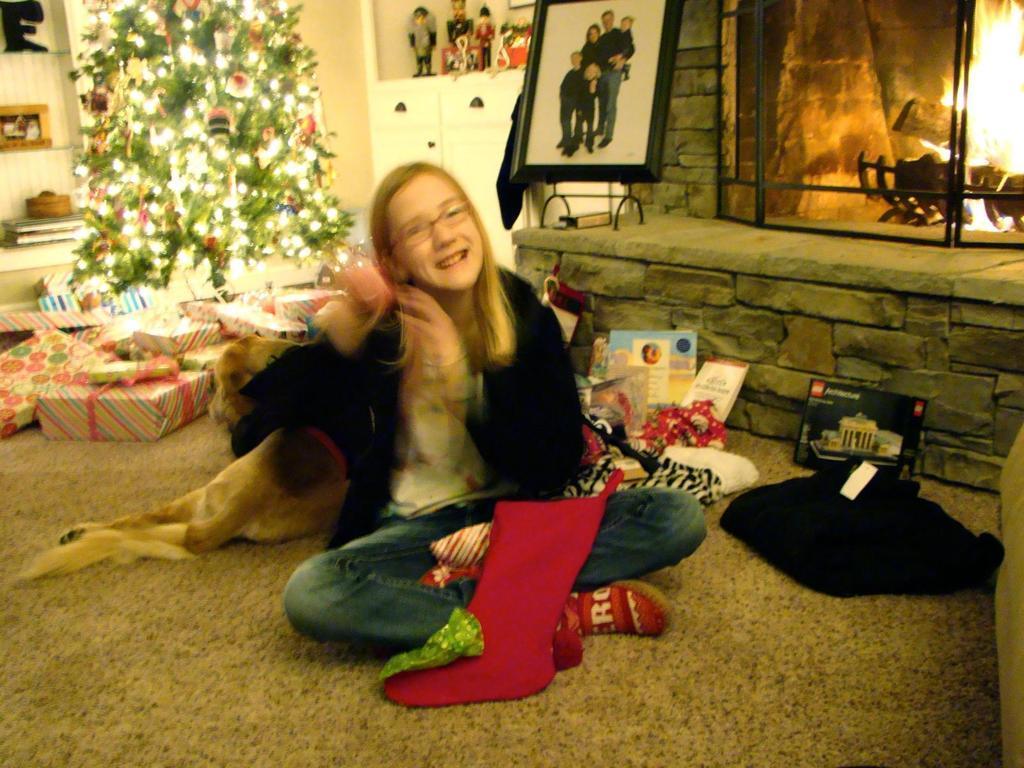Can you describe this image briefly? In this Image I see a girl who is sitting on the floor and she is smiling, I can also see an animal beside to her and there are few things over here. In the background I see the Christmas tree, presents, fire over here, photo frame and few things in the racks 